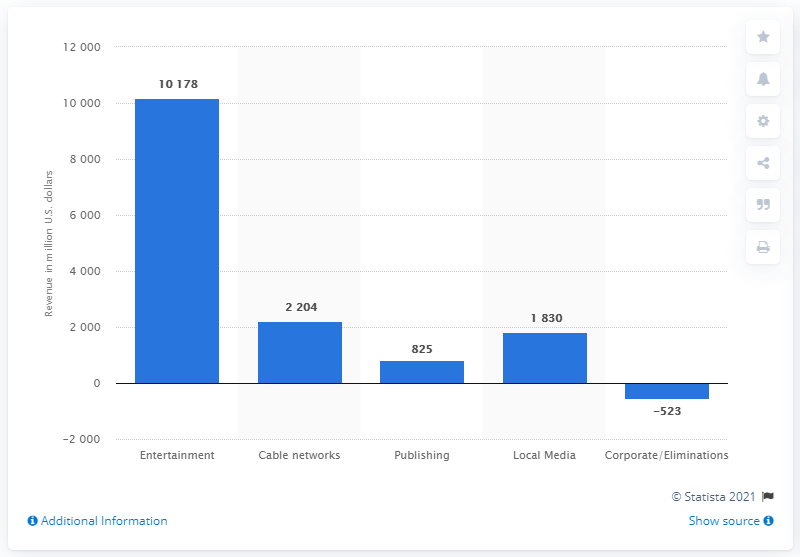Highlight a few significant elements in this photo. In 2018, the publishing business of CBS generated a total revenue of 825.. 